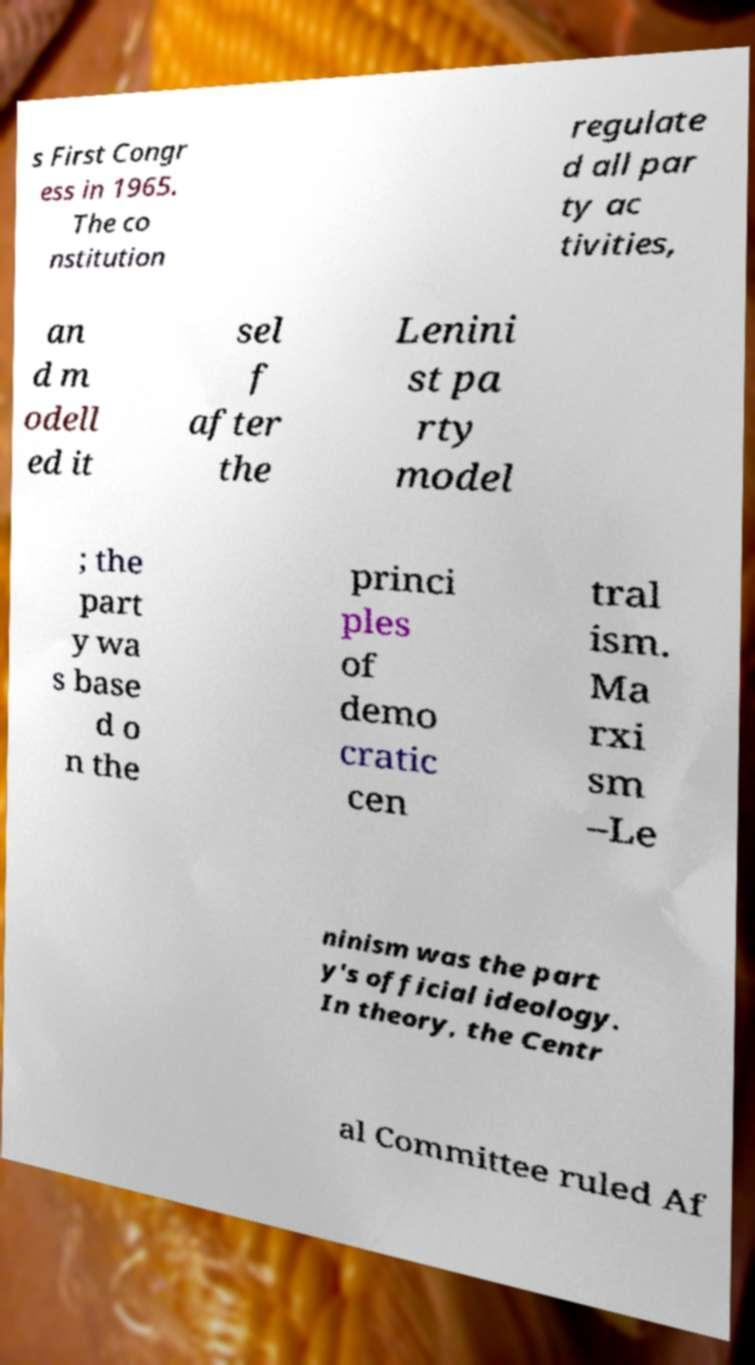Could you assist in decoding the text presented in this image and type it out clearly? s First Congr ess in 1965. The co nstitution regulate d all par ty ac tivities, an d m odell ed it sel f after the Lenini st pa rty model ; the part y wa s base d o n the princi ples of demo cratic cen tral ism. Ma rxi sm –Le ninism was the part y's official ideology. In theory, the Centr al Committee ruled Af 